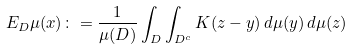Convert formula to latex. <formula><loc_0><loc_0><loc_500><loc_500>E _ { D } \mu ( x ) \colon = \frac { 1 } { \mu ( D ) } \int _ { D } \int _ { D ^ { c } } K ( z - y ) \, d \mu ( y ) \, d \mu ( z )</formula> 